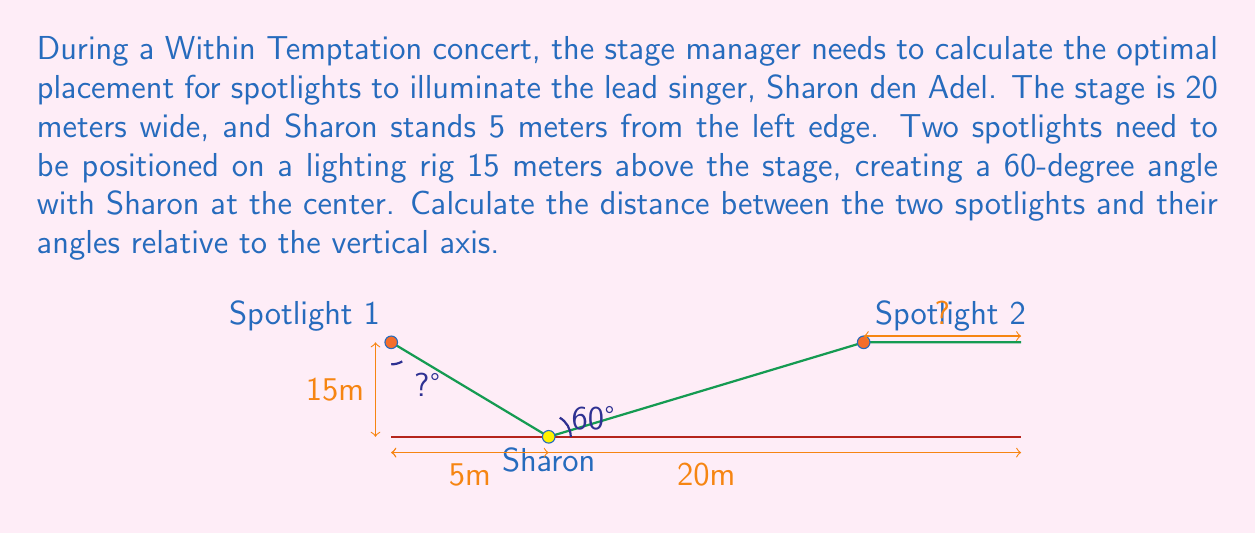Provide a solution to this math problem. Let's approach this problem step-by-step:

1) First, we need to find the horizontal distance from Sharon to each spotlight. We can do this using trigonometry.

2) In the right triangle formed by Sharon, one spotlight, and the point directly above Sharon on the lighting rig, we know:
   - The adjacent side (height) is 15 meters
   - The angle at Sharon is 30° (half of the 60° angle between the spotlights)

3) We can use the tangent function to find the horizontal distance:

   $$\tan(30°) = \frac{\text{opposite}}{\text{adjacent}} = \frac{x}{15}$$

4) Solving for x:
   $$x = 15 \tan(30°) = 15 \cdot \frac{\sqrt{3}}{3} \approx 8.66 \text{ meters}$$

5) The distance between the spotlights is twice this horizontal distance:
   $$\text{Distance between spotlights} = 2x \approx 17.32 \text{ meters}$$

6) To find the angle of each spotlight relative to the vertical axis, we can use the arctangent function:

   $$\theta = \arctan(\frac{8.66}{15}) \approx 30.0°$$

7) This angle is the same for both spotlights, just in opposite directions from the vertical.
Answer: Distance between spotlights: $17.32 \text{ m}$. Angle from vertical: $30.0°$ 